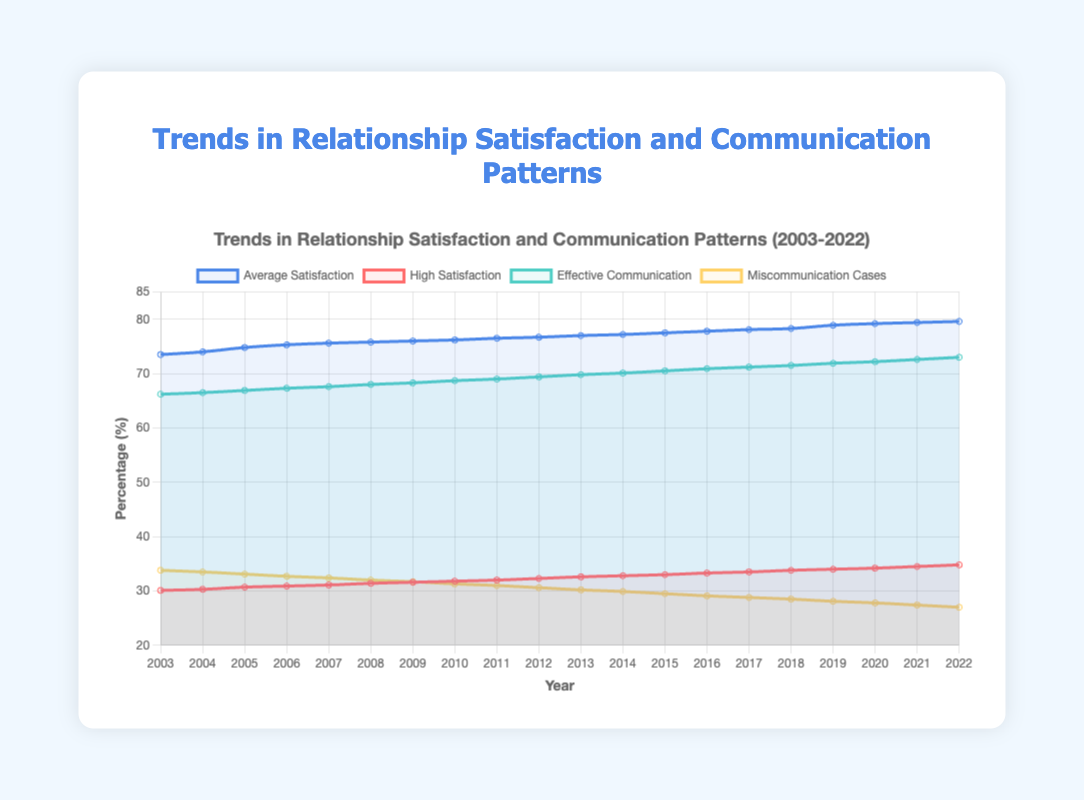How has the average relationship satisfaction changed from 2003 to 2022? Start with the average satisfaction value in 2003, which is 73.5%, and compare it to the value in 2022, which is 79.6%. Calculate the difference to understand the change.
Answer: The average relationship satisfaction increased by 6.1% Which year observed a higher increase in effective communication: 2004 to 2005 or 2005 to 2006? Examine the effective communication values for each year. From 2004 to 2005, the increase is from 66.5% to 66.9%, which is 0.4%. From 2005 to 2006, the increase is from 66.9% to 67.3%, which is also 0.4%.
Answer: Both periods observed the same increase, 0.4% Compare the trends in high relationship satisfaction and effective communication between 2010 and 2015. Look at the values for both metrics in 2010 and 2015. High satisfaction increased from 31.8% to 33.0%, a change of 1.2%. Effective communication increased from 68.7% to 70.5%, a change of 1.8%.
Answer: Effective communication increased more significantly Which metric had the steepest decrease over the years: miscommunication cases or high relationship satisfaction? Look at the starting and ending values of each metric. Miscommunication cases decreased from 33.8% to 27.0%, a change of 6.8%. High satisfaction increased, so it doesn't count.
Answer: Miscommunication cases had the steepest decrease What was the range of average relationship satisfaction values between 2003 and 2022? Identify the minimum and maximum values from 2003 to 2022. The minimum value is 73.5% (2003) and the maximum is 79.6% (2022). Calculate the range: 79.6 - 73.5.
Answer: The range is 6.1% Are the trends in high satisfaction and effective communication positively correlated? Look at the overall direction of both trends from 2003 to 2022. High satisfaction increased from 30.1% to 34.8%, an upward trend. Effective communication increased from 66.2% to 73.0%, also an upward trend. Therefore, both show a positive trend.
Answer: Yes, they are positively correlated Which year had the lowest value of miscommunication cases, and what was that value? Evaluate the miscommunication cases percentages year by year from 2003 to 2022. The lowest value appears in 2022 with 27.0%.
Answer: The year is 2022, and the value is 27.0% What was the percent increase in high relationship satisfaction from 2019 to 2022? Determine the values in 2019 and 2022, which are 34.0% and 34.8%, respectively. Calculate the percent increase: ((34.8 - 34.0) / 34.0) * 100.
Answer: The percent increase is about 2.35% How do the average satisfaction and effective communication trends compare visually? Examine the lines representing these trends. Both lines generally move upward, indicating improvement. The average satisfaction line is marked in blue, and effective communication in green.
Answer: Both trends show an upward movement Comparing the average satisfaction and high satisfaction rates in 2015, which was higher and by how much? Look at the values for 2015: the average satisfaction was 77.5%, and high satisfaction was 33.0%. Calculate the difference: 77.5 - 33.0.
Answer: The average satisfaction was higher by 44.5% 